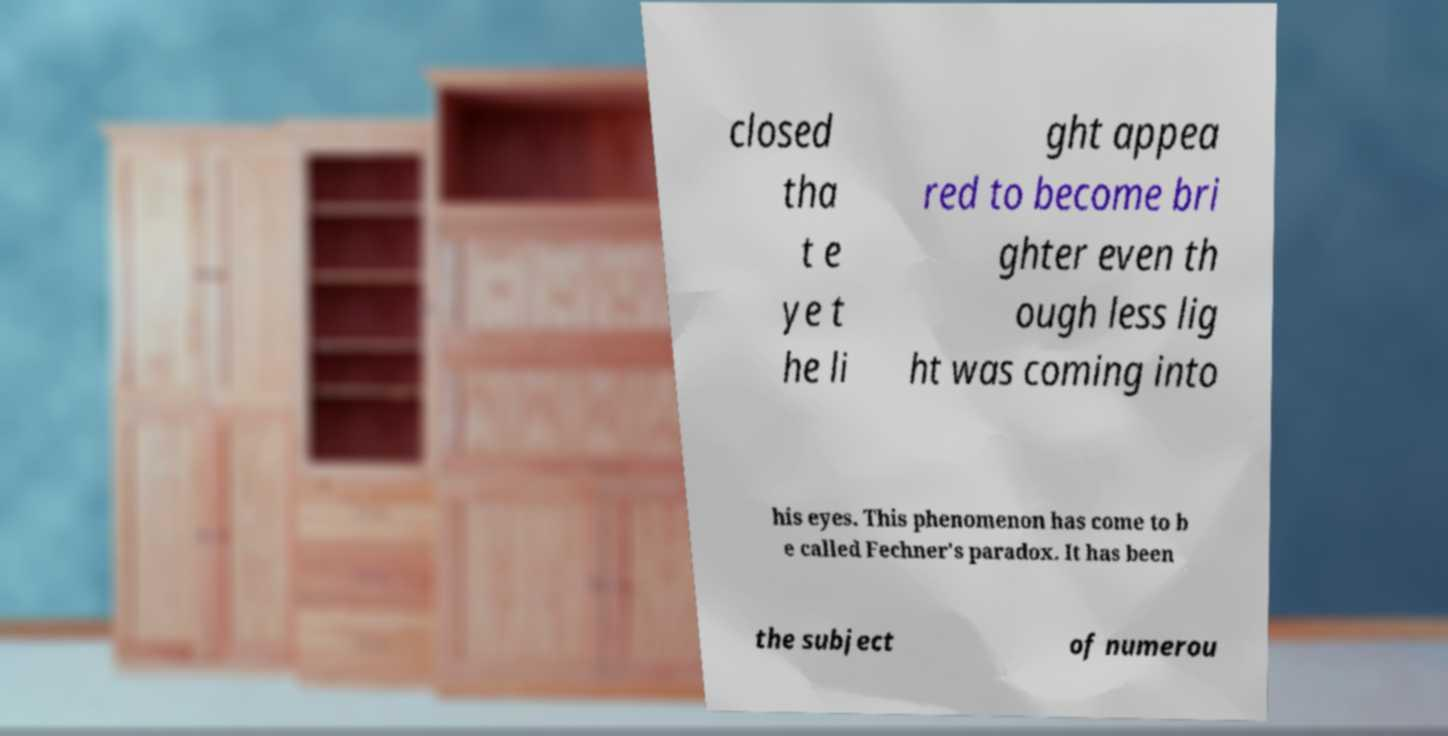Can you read and provide the text displayed in the image?This photo seems to have some interesting text. Can you extract and type it out for me? closed tha t e ye t he li ght appea red to become bri ghter even th ough less lig ht was coming into his eyes. This phenomenon has come to b e called Fechner's paradox. It has been the subject of numerou 